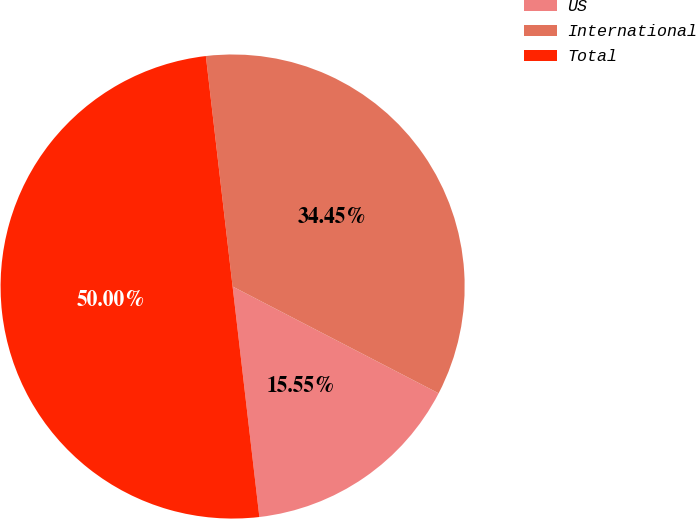<chart> <loc_0><loc_0><loc_500><loc_500><pie_chart><fcel>US<fcel>International<fcel>Total<nl><fcel>15.55%<fcel>34.45%<fcel>50.0%<nl></chart> 